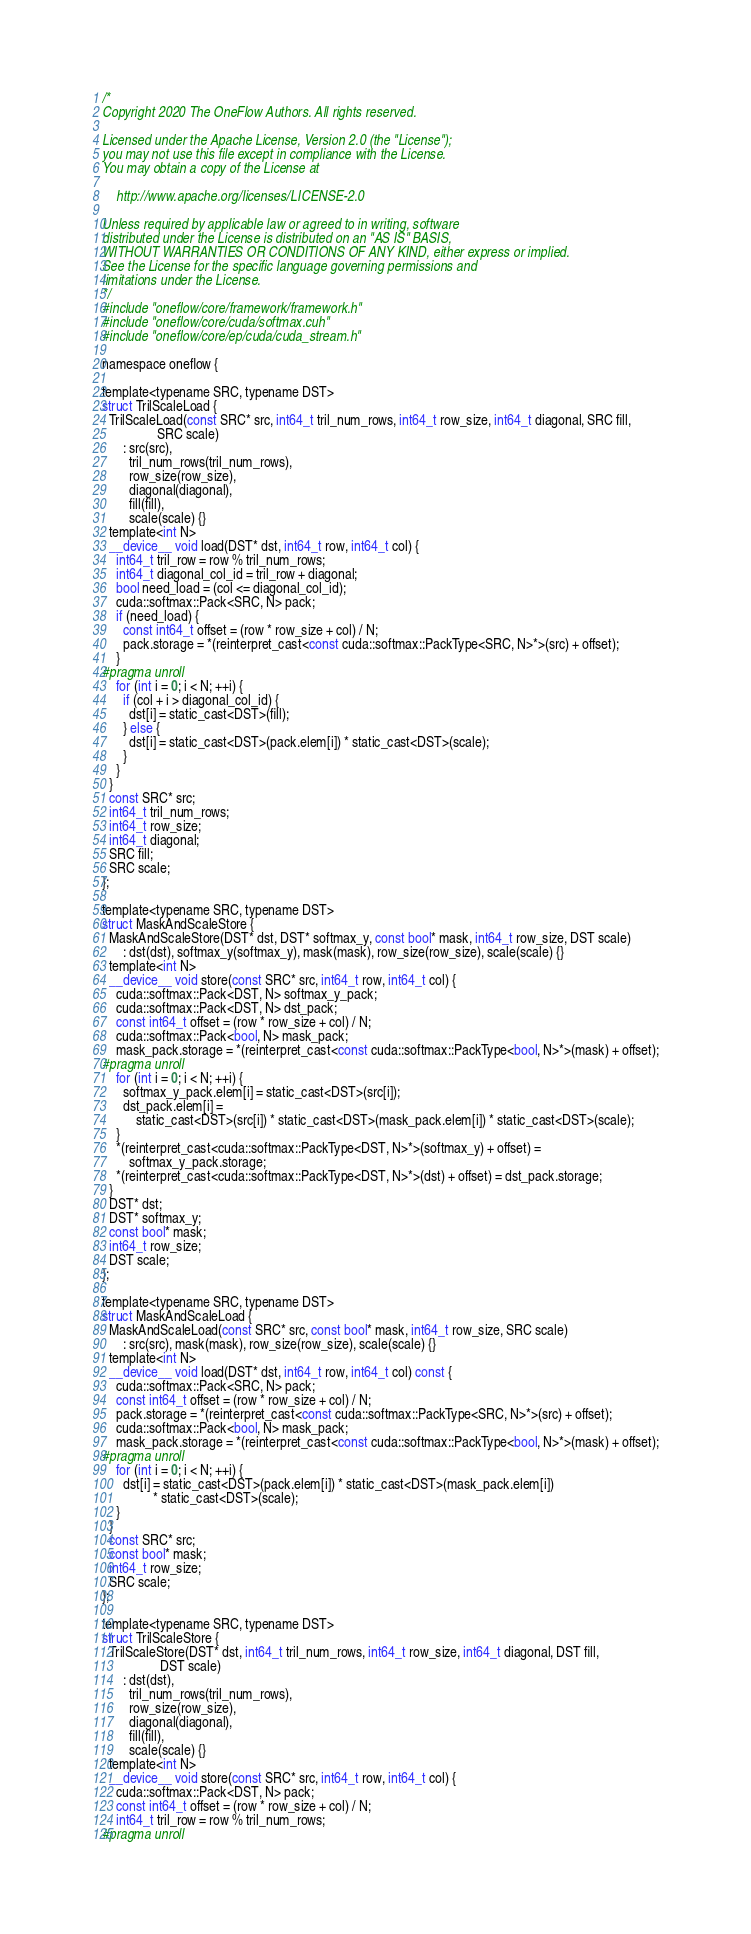Convert code to text. <code><loc_0><loc_0><loc_500><loc_500><_Cuda_>/*
Copyright 2020 The OneFlow Authors. All rights reserved.

Licensed under the Apache License, Version 2.0 (the "License");
you may not use this file except in compliance with the License.
You may obtain a copy of the License at

    http://www.apache.org/licenses/LICENSE-2.0

Unless required by applicable law or agreed to in writing, software
distributed under the License is distributed on an "AS IS" BASIS,
WITHOUT WARRANTIES OR CONDITIONS OF ANY KIND, either express or implied.
See the License for the specific language governing permissions and
limitations under the License.
*/
#include "oneflow/core/framework/framework.h"
#include "oneflow/core/cuda/softmax.cuh"
#include "oneflow/core/ep/cuda/cuda_stream.h"

namespace oneflow {

template<typename SRC, typename DST>
struct TrilScaleLoad {
  TrilScaleLoad(const SRC* src, int64_t tril_num_rows, int64_t row_size, int64_t diagonal, SRC fill,
                SRC scale)
      : src(src),
        tril_num_rows(tril_num_rows),
        row_size(row_size),
        diagonal(diagonal),
        fill(fill),
        scale(scale) {}
  template<int N>
  __device__ void load(DST* dst, int64_t row, int64_t col) {
    int64_t tril_row = row % tril_num_rows;
    int64_t diagonal_col_id = tril_row + diagonal;
    bool need_load = (col <= diagonal_col_id);
    cuda::softmax::Pack<SRC, N> pack;
    if (need_load) {
      const int64_t offset = (row * row_size + col) / N;
      pack.storage = *(reinterpret_cast<const cuda::softmax::PackType<SRC, N>*>(src) + offset);
    }
#pragma unroll
    for (int i = 0; i < N; ++i) {
      if (col + i > diagonal_col_id) {
        dst[i] = static_cast<DST>(fill);
      } else {
        dst[i] = static_cast<DST>(pack.elem[i]) * static_cast<DST>(scale);
      }
    }
  }
  const SRC* src;
  int64_t tril_num_rows;
  int64_t row_size;
  int64_t diagonal;
  SRC fill;
  SRC scale;
};

template<typename SRC, typename DST>
struct MaskAndScaleStore {
  MaskAndScaleStore(DST* dst, DST* softmax_y, const bool* mask, int64_t row_size, DST scale)
      : dst(dst), softmax_y(softmax_y), mask(mask), row_size(row_size), scale(scale) {}
  template<int N>
  __device__ void store(const SRC* src, int64_t row, int64_t col) {
    cuda::softmax::Pack<DST, N> softmax_y_pack;
    cuda::softmax::Pack<DST, N> dst_pack;
    const int64_t offset = (row * row_size + col) / N;
    cuda::softmax::Pack<bool, N> mask_pack;
    mask_pack.storage = *(reinterpret_cast<const cuda::softmax::PackType<bool, N>*>(mask) + offset);
#pragma unroll
    for (int i = 0; i < N; ++i) {
      softmax_y_pack.elem[i] = static_cast<DST>(src[i]);
      dst_pack.elem[i] =
          static_cast<DST>(src[i]) * static_cast<DST>(mask_pack.elem[i]) * static_cast<DST>(scale);
    }
    *(reinterpret_cast<cuda::softmax::PackType<DST, N>*>(softmax_y) + offset) =
        softmax_y_pack.storage;
    *(reinterpret_cast<cuda::softmax::PackType<DST, N>*>(dst) + offset) = dst_pack.storage;
  }
  DST* dst;
  DST* softmax_y;
  const bool* mask;
  int64_t row_size;
  DST scale;
};

template<typename SRC, typename DST>
struct MaskAndScaleLoad {
  MaskAndScaleLoad(const SRC* src, const bool* mask, int64_t row_size, SRC scale)
      : src(src), mask(mask), row_size(row_size), scale(scale) {}
  template<int N>
  __device__ void load(DST* dst, int64_t row, int64_t col) const {
    cuda::softmax::Pack<SRC, N> pack;
    const int64_t offset = (row * row_size + col) / N;
    pack.storage = *(reinterpret_cast<const cuda::softmax::PackType<SRC, N>*>(src) + offset);
    cuda::softmax::Pack<bool, N> mask_pack;
    mask_pack.storage = *(reinterpret_cast<const cuda::softmax::PackType<bool, N>*>(mask) + offset);
#pragma unroll
    for (int i = 0; i < N; ++i) {
      dst[i] = static_cast<DST>(pack.elem[i]) * static_cast<DST>(mask_pack.elem[i])
               * static_cast<DST>(scale);
    }
  }
  const SRC* src;
  const bool* mask;
  int64_t row_size;
  SRC scale;
};

template<typename SRC, typename DST>
struct TrilScaleStore {
  TrilScaleStore(DST* dst, int64_t tril_num_rows, int64_t row_size, int64_t diagonal, DST fill,
                 DST scale)
      : dst(dst),
        tril_num_rows(tril_num_rows),
        row_size(row_size),
        diagonal(diagonal),
        fill(fill),
        scale(scale) {}
  template<int N>
  __device__ void store(const SRC* src, int64_t row, int64_t col) {
    cuda::softmax::Pack<DST, N> pack;
    const int64_t offset = (row * row_size + col) / N;
    int64_t tril_row = row % tril_num_rows;
#pragma unroll</code> 